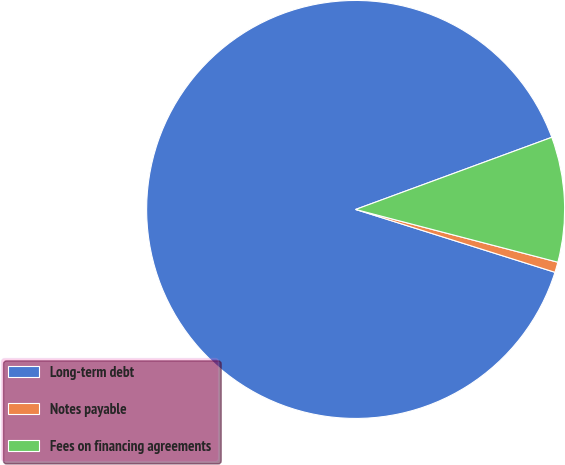Convert chart to OTSL. <chart><loc_0><loc_0><loc_500><loc_500><pie_chart><fcel>Long-term debt<fcel>Notes payable<fcel>Fees on financing agreements<nl><fcel>89.52%<fcel>0.8%<fcel>9.67%<nl></chart> 